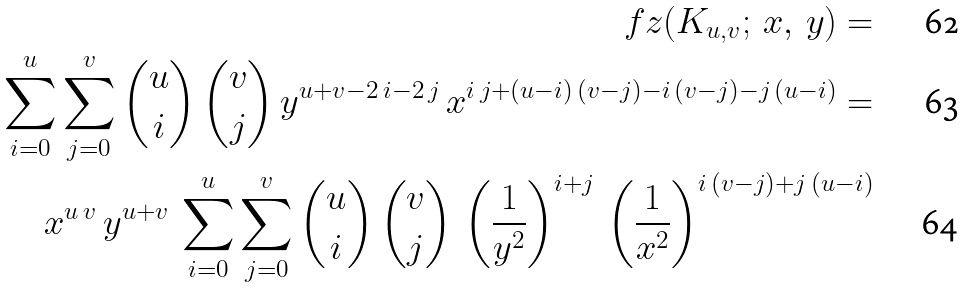<formula> <loc_0><loc_0><loc_500><loc_500>\ f z ( K _ { u , v } ; \, x , \, y ) = \\ \sum _ { i = 0 } ^ { u } \sum _ { j = 0 } ^ { v } \binom { u } { i } \, \binom { v } { j } \, y ^ { u + v - 2 \, i - 2 \, j } \, x ^ { i \, j + ( u - i ) \, ( v - j ) - i \, ( v - j ) - j \, ( u - i ) } = \\ x ^ { u \, v } \, y ^ { u + v } \, \sum _ { i = 0 } ^ { u } \sum _ { j = 0 } ^ { v } \binom { u } { i } \, \binom { v } { j } \, \left ( \frac { 1 } { y ^ { 2 } } \right ) ^ { i + j } \, \left ( \frac { 1 } { x ^ { 2 } } \right ) ^ { i \, ( v - j ) + j \, ( u - i ) }</formula> 